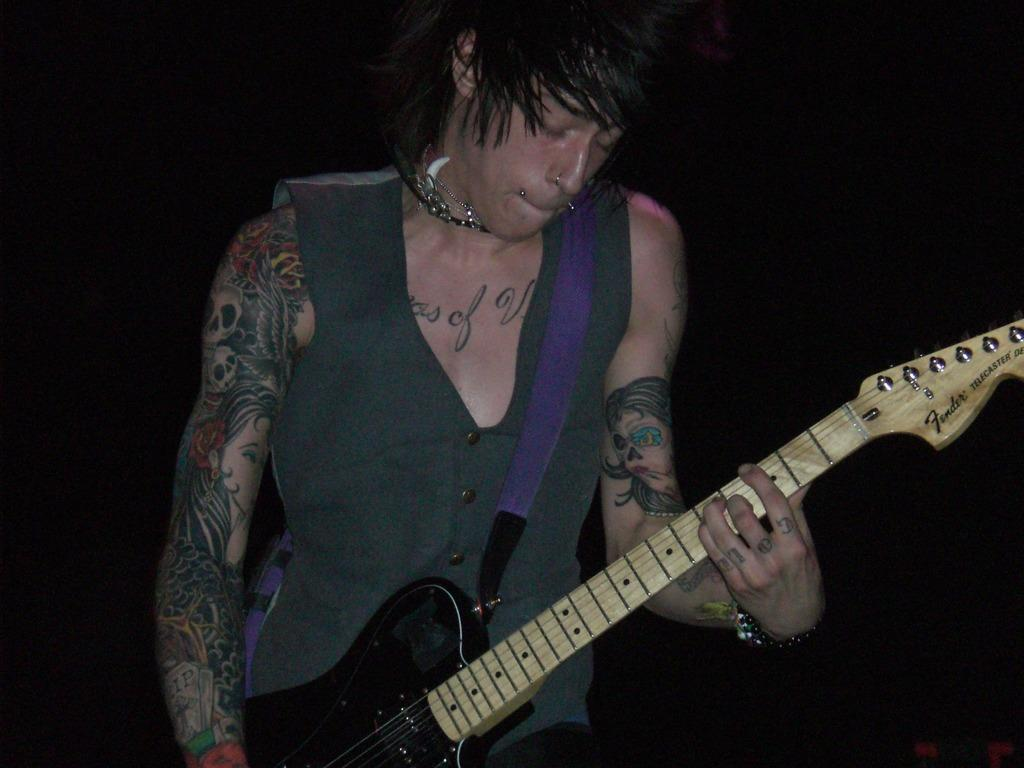What is the main subject of the image? The main subject of the image is a man. What is the man doing in the image? The man is playing a guitar in the image. How many giants can be seen in the image? There are no giants present in the image; it features a man playing a guitar. What type of gate is visible in the image? There is no gate present in the image. 